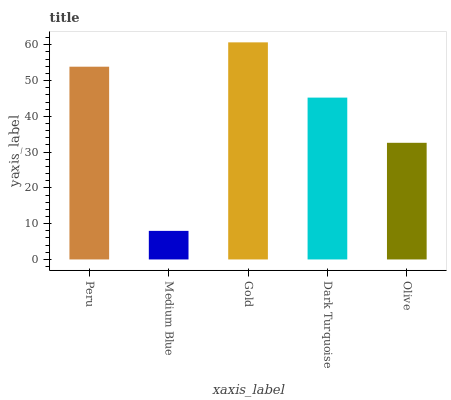Is Medium Blue the minimum?
Answer yes or no. Yes. Is Gold the maximum?
Answer yes or no. Yes. Is Gold the minimum?
Answer yes or no. No. Is Medium Blue the maximum?
Answer yes or no. No. Is Gold greater than Medium Blue?
Answer yes or no. Yes. Is Medium Blue less than Gold?
Answer yes or no. Yes. Is Medium Blue greater than Gold?
Answer yes or no. No. Is Gold less than Medium Blue?
Answer yes or no. No. Is Dark Turquoise the high median?
Answer yes or no. Yes. Is Dark Turquoise the low median?
Answer yes or no. Yes. Is Gold the high median?
Answer yes or no. No. Is Olive the low median?
Answer yes or no. No. 